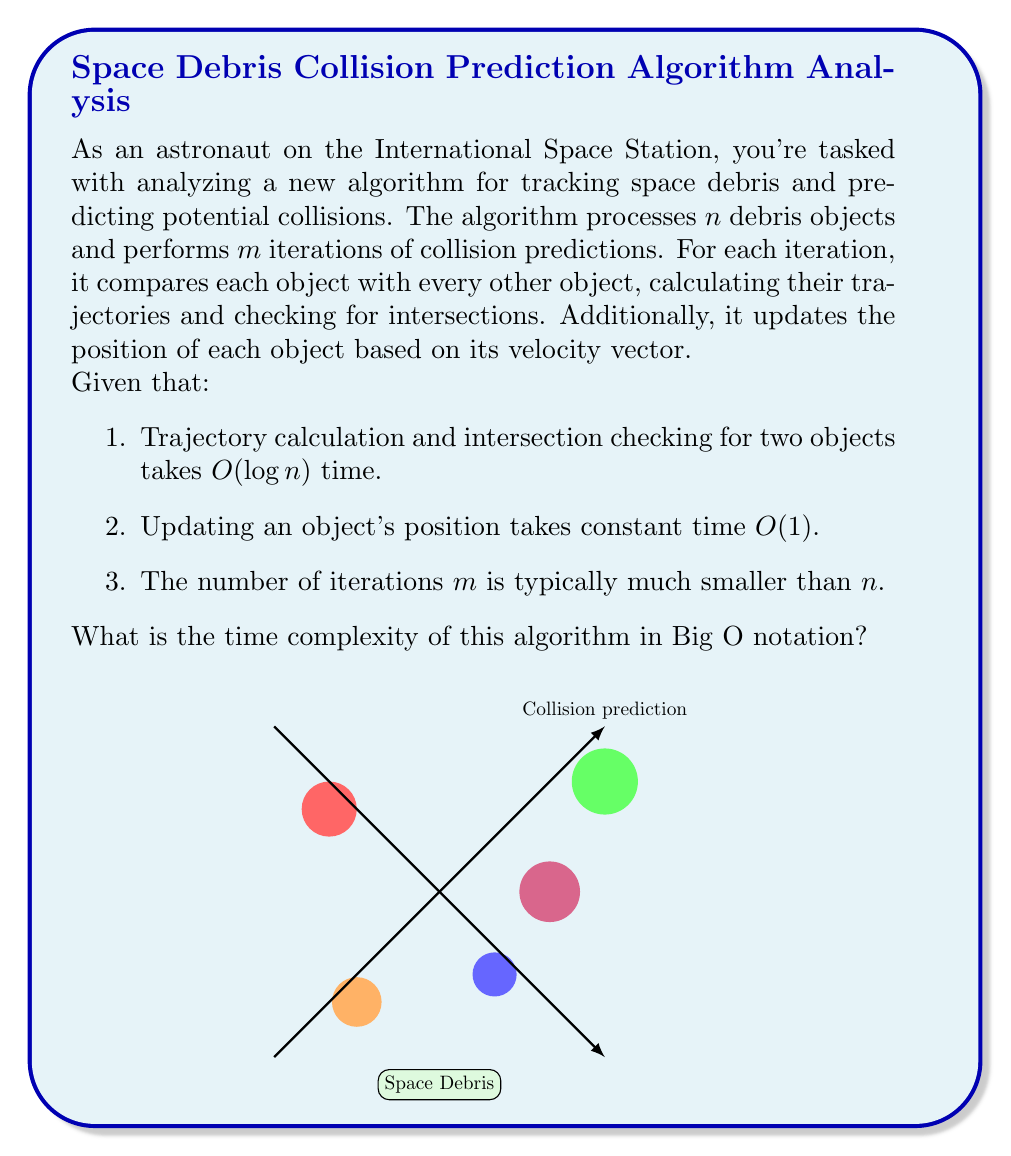Help me with this question. Let's break down the algorithm and analyze its time complexity step by step:

1. The algorithm processes $n$ debris objects over $m$ iterations.

2. In each iteration:
   a) It compares each object with every other object. This results in $\binom{n}{2} = \frac{n(n-1)}{2}$ comparisons.
   b) For each comparison, it calculates trajectories and checks for intersections, which takes $O(\log n)$ time.
   c) It updates the position of each object, which takes $O(1)$ time for each of the $n$ objects.

3. Let's calculate the time complexity for a single iteration:
   - Comparisons and intersection checks: $O(\frac{n(n-1)}{2} \cdot \log n) = O(n^2 \log n)$
   - Position updates: $O(n)$

4. The total time complexity for a single iteration is dominated by the comparisons and intersection checks: $O(n^2 \log n)$

5. Since there are $m$ iterations, we multiply the single iteration complexity by $m$:
   $O(m \cdot n^2 \log n)$

6. Given that $m$ is typically much smaller than $n$, we can consider it as a constant factor in terms of Big O notation.

Therefore, the overall time complexity of the algorithm is $O(n^2 \log n)$.
Answer: $O(n^2 \log n)$ 